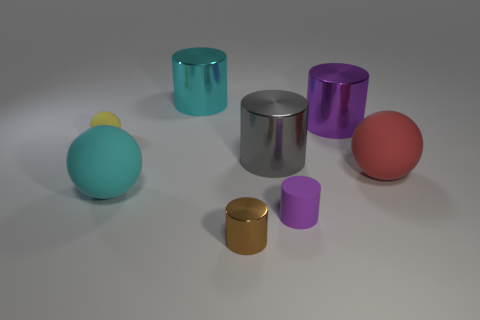Subtract all gray metallic cylinders. How many cylinders are left? 4 Subtract all brown cylinders. How many cylinders are left? 4 Subtract 1 spheres. How many spheres are left? 2 Add 1 small things. How many objects exist? 9 Subtract all blue cylinders. Subtract all cyan blocks. How many cylinders are left? 5 Subtract all cylinders. How many objects are left? 3 Add 6 big purple cylinders. How many big purple cylinders are left? 7 Add 2 purple metallic cylinders. How many purple metallic cylinders exist? 3 Subtract 0 purple balls. How many objects are left? 8 Subtract all tiny brown shiny objects. Subtract all tiny green rubber things. How many objects are left? 7 